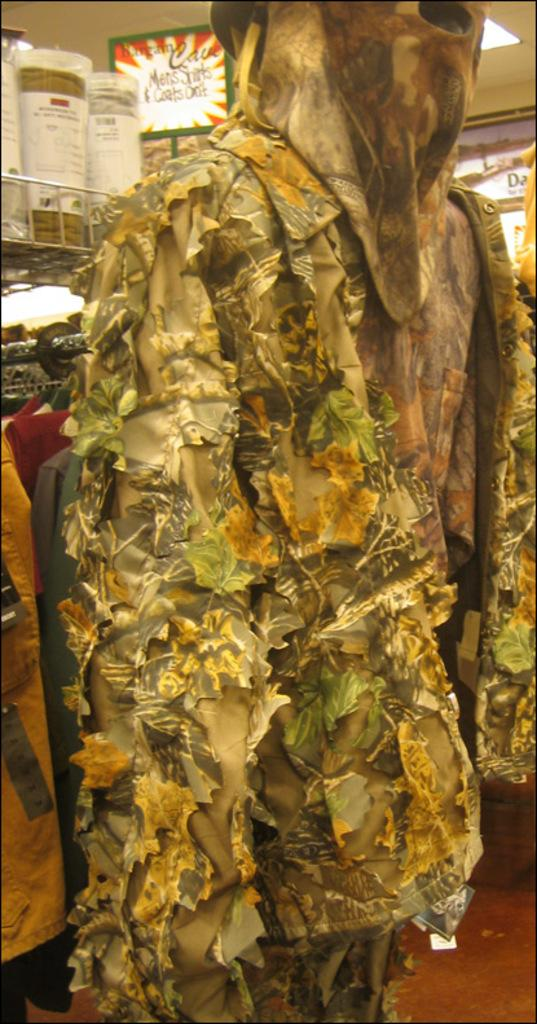What is present on the floor in the image? There are clothes on the floor in the image. What can be seen in the background of the image? There is a board and a light in the background of the image, with the sky visible as well. What type of furniture is present in the wilderness in the image? There is no furniture or wilderness present in the image; it features clothes on the floor and a background with a board, light, and sky. 